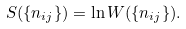<formula> <loc_0><loc_0><loc_500><loc_500>S ( \{ n _ { i j } \} ) = \ln W ( \{ n _ { i j } \} ) .</formula> 